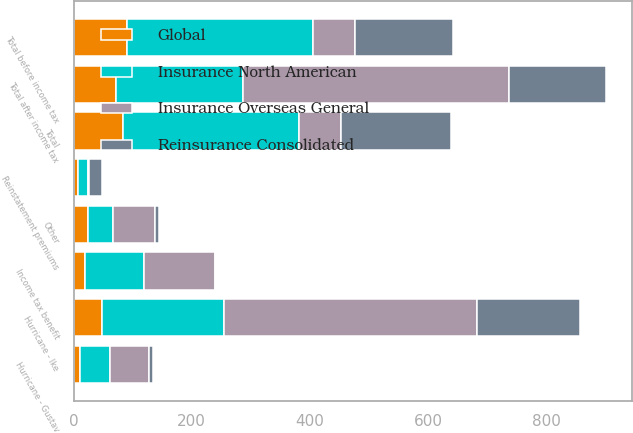<chart> <loc_0><loc_0><loc_500><loc_500><stacked_bar_chart><ecel><fcel>Hurricane - Gustav<fcel>Hurricane - Ike<fcel>Other<fcel>Total<fcel>Reinstatement premiums<fcel>Total before income tax<fcel>Income tax benefit<fcel>Total after income tax<nl><fcel>Insurance North American<fcel>50<fcel>206<fcel>42<fcel>298<fcel>16<fcel>314<fcel>99<fcel>215<nl><fcel>Global<fcel>11<fcel>48<fcel>24<fcel>83<fcel>8<fcel>91<fcel>20<fcel>71<nl><fcel>Reinsurance Consolidated<fcel>6<fcel>174<fcel>6<fcel>186<fcel>21<fcel>165<fcel>1<fcel>164<nl><fcel>Insurance Overseas General<fcel>67<fcel>428<fcel>72<fcel>71.5<fcel>3<fcel>71.5<fcel>120<fcel>450<nl></chart> 